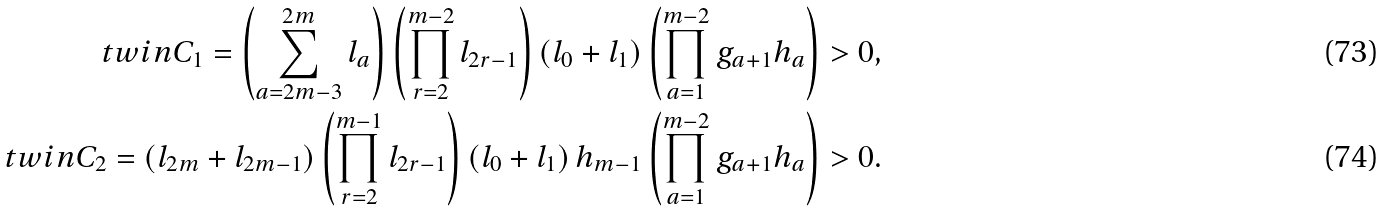<formula> <loc_0><loc_0><loc_500><loc_500>\ t w i n C _ { 1 } = \left ( \sum _ { a = 2 m - 3 } ^ { 2 m } l _ { a } \right ) \left ( \prod _ { r = 2 } ^ { m - 2 } l _ { 2 r - 1 } \right ) ( l _ { 0 } + l _ { 1 } ) \left ( \prod _ { a = 1 } ^ { m - 2 } g _ { a + 1 } h _ { a } \right ) > 0 , \\ \ t w i n C _ { 2 } = ( l _ { 2 m } + l _ { 2 m - 1 } ) \left ( \prod _ { r = 2 } ^ { m - 1 } l _ { 2 r - 1 } \right ) ( l _ { 0 } + l _ { 1 } ) \, h _ { m - 1 } \left ( \prod _ { a = 1 } ^ { m - 2 } g _ { a + 1 } h _ { a } \right ) > 0 .</formula> 